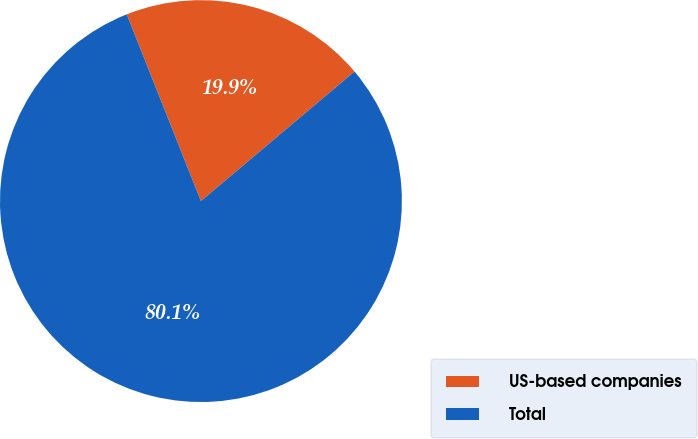Convert chart. <chart><loc_0><loc_0><loc_500><loc_500><pie_chart><fcel>US-based companies<fcel>Total<nl><fcel>19.87%<fcel>80.13%<nl></chart> 